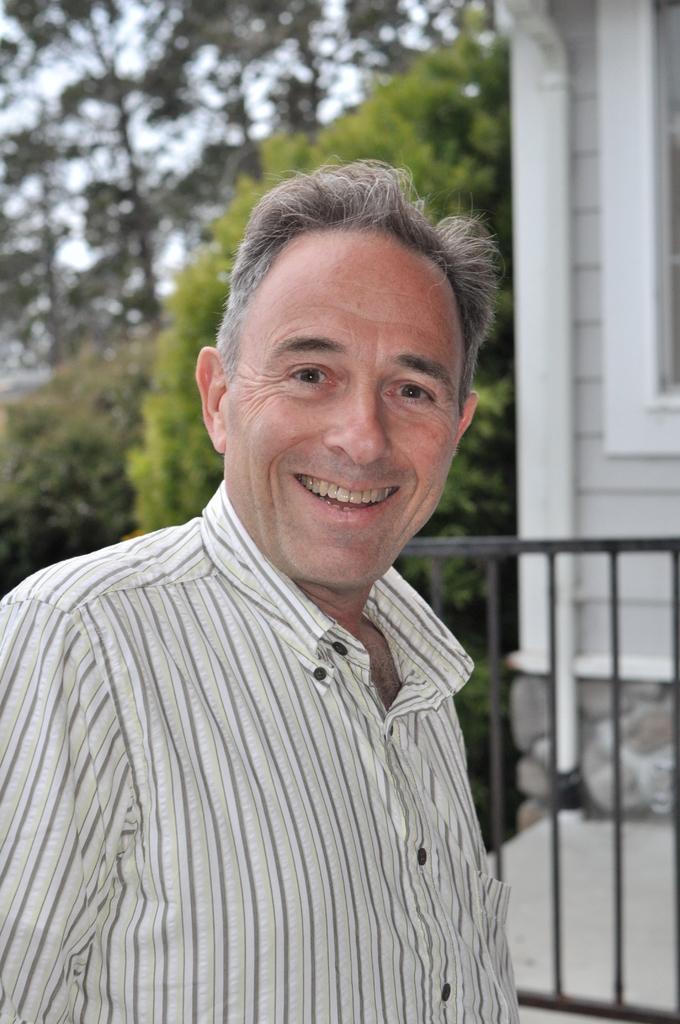Can you describe this image briefly? In this picture there is a person smiling and there is a building in the right corner and there are trees in the background. 